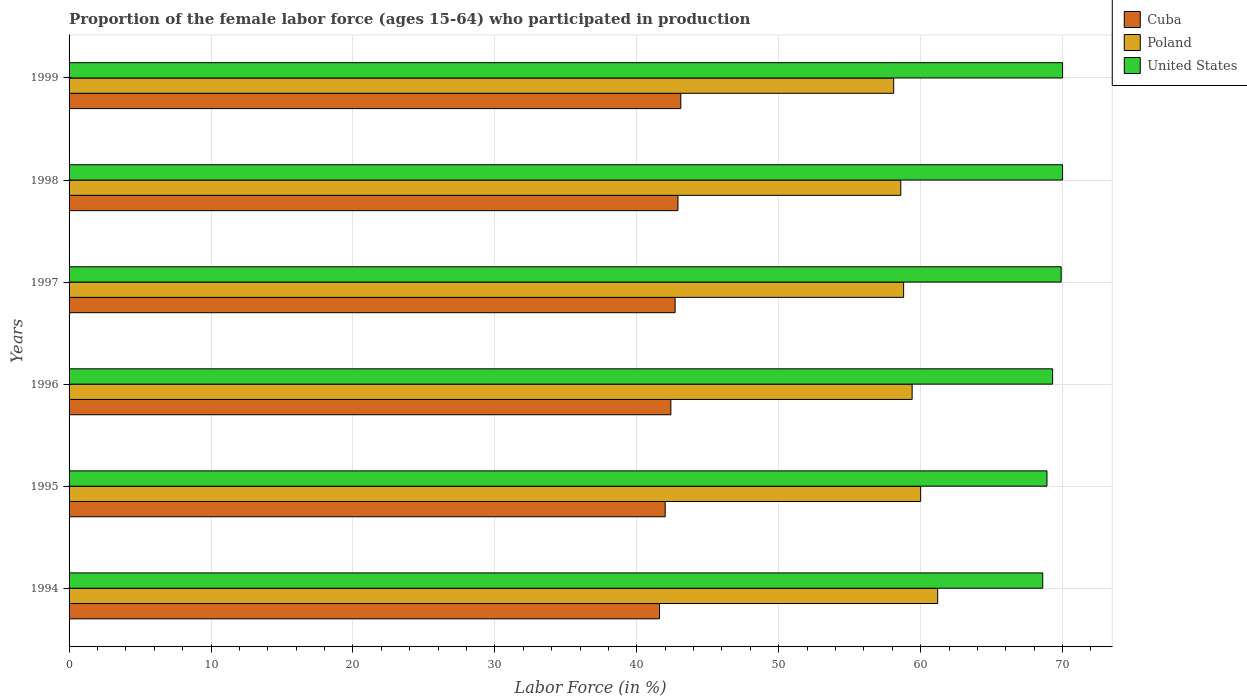How many different coloured bars are there?
Your response must be concise. 3. Are the number of bars on each tick of the Y-axis equal?
Provide a short and direct response. Yes. How many bars are there on the 2nd tick from the top?
Give a very brief answer. 3. What is the label of the 4th group of bars from the top?
Your answer should be compact. 1996. What is the proportion of the female labor force who participated in production in United States in 1995?
Provide a short and direct response. 68.9. Across all years, what is the maximum proportion of the female labor force who participated in production in United States?
Offer a very short reply. 70. Across all years, what is the minimum proportion of the female labor force who participated in production in United States?
Provide a short and direct response. 68.6. What is the total proportion of the female labor force who participated in production in Cuba in the graph?
Keep it short and to the point. 254.7. What is the difference between the proportion of the female labor force who participated in production in Poland in 1997 and the proportion of the female labor force who participated in production in Cuba in 1995?
Your answer should be very brief. 16.8. What is the average proportion of the female labor force who participated in production in Poland per year?
Your answer should be very brief. 59.35. In the year 1998, what is the difference between the proportion of the female labor force who participated in production in Poland and proportion of the female labor force who participated in production in Cuba?
Offer a terse response. 15.7. What is the ratio of the proportion of the female labor force who participated in production in Poland in 1995 to that in 1997?
Offer a terse response. 1.02. What is the difference between the highest and the second highest proportion of the female labor force who participated in production in Cuba?
Offer a very short reply. 0.2. What is the difference between the highest and the lowest proportion of the female labor force who participated in production in United States?
Your response must be concise. 1.4. In how many years, is the proportion of the female labor force who participated in production in United States greater than the average proportion of the female labor force who participated in production in United States taken over all years?
Offer a terse response. 3. Is the sum of the proportion of the female labor force who participated in production in Poland in 1994 and 1999 greater than the maximum proportion of the female labor force who participated in production in United States across all years?
Your answer should be compact. Yes. What does the 3rd bar from the top in 1997 represents?
Provide a succinct answer. Cuba. What does the 1st bar from the bottom in 1997 represents?
Provide a short and direct response. Cuba. How many bars are there?
Keep it short and to the point. 18. Are all the bars in the graph horizontal?
Ensure brevity in your answer.  Yes. What is the difference between two consecutive major ticks on the X-axis?
Provide a short and direct response. 10. Are the values on the major ticks of X-axis written in scientific E-notation?
Ensure brevity in your answer.  No. Does the graph contain grids?
Ensure brevity in your answer.  Yes. Where does the legend appear in the graph?
Keep it short and to the point. Top right. What is the title of the graph?
Offer a terse response. Proportion of the female labor force (ages 15-64) who participated in production. Does "Sub-Saharan Africa (developing only)" appear as one of the legend labels in the graph?
Your answer should be compact. No. What is the Labor Force (in %) of Cuba in 1994?
Make the answer very short. 41.6. What is the Labor Force (in %) of Poland in 1994?
Give a very brief answer. 61.2. What is the Labor Force (in %) in United States in 1994?
Offer a terse response. 68.6. What is the Labor Force (in %) in Cuba in 1995?
Provide a short and direct response. 42. What is the Labor Force (in %) of United States in 1995?
Your answer should be compact. 68.9. What is the Labor Force (in %) of Cuba in 1996?
Provide a short and direct response. 42.4. What is the Labor Force (in %) of Poland in 1996?
Keep it short and to the point. 59.4. What is the Labor Force (in %) of United States in 1996?
Provide a short and direct response. 69.3. What is the Labor Force (in %) in Cuba in 1997?
Make the answer very short. 42.7. What is the Labor Force (in %) in Poland in 1997?
Provide a succinct answer. 58.8. What is the Labor Force (in %) in United States in 1997?
Offer a very short reply. 69.9. What is the Labor Force (in %) in Cuba in 1998?
Provide a succinct answer. 42.9. What is the Labor Force (in %) in Poland in 1998?
Your response must be concise. 58.6. What is the Labor Force (in %) in Cuba in 1999?
Your response must be concise. 43.1. What is the Labor Force (in %) of Poland in 1999?
Keep it short and to the point. 58.1. What is the Labor Force (in %) of United States in 1999?
Give a very brief answer. 70. Across all years, what is the maximum Labor Force (in %) of Cuba?
Ensure brevity in your answer.  43.1. Across all years, what is the maximum Labor Force (in %) in Poland?
Make the answer very short. 61.2. Across all years, what is the maximum Labor Force (in %) of United States?
Keep it short and to the point. 70. Across all years, what is the minimum Labor Force (in %) of Cuba?
Your response must be concise. 41.6. Across all years, what is the minimum Labor Force (in %) in Poland?
Your response must be concise. 58.1. Across all years, what is the minimum Labor Force (in %) in United States?
Your answer should be compact. 68.6. What is the total Labor Force (in %) of Cuba in the graph?
Offer a very short reply. 254.7. What is the total Labor Force (in %) of Poland in the graph?
Your response must be concise. 356.1. What is the total Labor Force (in %) of United States in the graph?
Your answer should be very brief. 416.7. What is the difference between the Labor Force (in %) of Cuba in 1994 and that in 1995?
Your answer should be compact. -0.4. What is the difference between the Labor Force (in %) in Poland in 1994 and that in 1995?
Make the answer very short. 1.2. What is the difference between the Labor Force (in %) in Cuba in 1994 and that in 1997?
Your answer should be compact. -1.1. What is the difference between the Labor Force (in %) in Poland in 1994 and that in 1997?
Your answer should be compact. 2.4. What is the difference between the Labor Force (in %) of Poland in 1994 and that in 1998?
Your response must be concise. 2.6. What is the difference between the Labor Force (in %) of United States in 1994 and that in 1998?
Your response must be concise. -1.4. What is the difference between the Labor Force (in %) in Cuba in 1994 and that in 1999?
Make the answer very short. -1.5. What is the difference between the Labor Force (in %) in Poland in 1994 and that in 1999?
Your response must be concise. 3.1. What is the difference between the Labor Force (in %) in United States in 1994 and that in 1999?
Give a very brief answer. -1.4. What is the difference between the Labor Force (in %) of United States in 1995 and that in 1996?
Keep it short and to the point. -0.4. What is the difference between the Labor Force (in %) of Poland in 1995 and that in 1997?
Give a very brief answer. 1.2. What is the difference between the Labor Force (in %) in Poland in 1996 and that in 1997?
Provide a short and direct response. 0.6. What is the difference between the Labor Force (in %) of Poland in 1996 and that in 1998?
Offer a terse response. 0.8. What is the difference between the Labor Force (in %) of Poland in 1996 and that in 1999?
Keep it short and to the point. 1.3. What is the difference between the Labor Force (in %) in United States in 1996 and that in 1999?
Keep it short and to the point. -0.7. What is the difference between the Labor Force (in %) of Cuba in 1997 and that in 1999?
Provide a succinct answer. -0.4. What is the difference between the Labor Force (in %) of Poland in 1997 and that in 1999?
Your answer should be very brief. 0.7. What is the difference between the Labor Force (in %) in Poland in 1998 and that in 1999?
Give a very brief answer. 0.5. What is the difference between the Labor Force (in %) of United States in 1998 and that in 1999?
Provide a succinct answer. 0. What is the difference between the Labor Force (in %) in Cuba in 1994 and the Labor Force (in %) in Poland in 1995?
Give a very brief answer. -18.4. What is the difference between the Labor Force (in %) of Cuba in 1994 and the Labor Force (in %) of United States in 1995?
Provide a short and direct response. -27.3. What is the difference between the Labor Force (in %) of Cuba in 1994 and the Labor Force (in %) of Poland in 1996?
Offer a terse response. -17.8. What is the difference between the Labor Force (in %) in Cuba in 1994 and the Labor Force (in %) in United States in 1996?
Make the answer very short. -27.7. What is the difference between the Labor Force (in %) in Poland in 1994 and the Labor Force (in %) in United States in 1996?
Make the answer very short. -8.1. What is the difference between the Labor Force (in %) in Cuba in 1994 and the Labor Force (in %) in Poland in 1997?
Provide a short and direct response. -17.2. What is the difference between the Labor Force (in %) in Cuba in 1994 and the Labor Force (in %) in United States in 1997?
Your answer should be compact. -28.3. What is the difference between the Labor Force (in %) of Poland in 1994 and the Labor Force (in %) of United States in 1997?
Ensure brevity in your answer.  -8.7. What is the difference between the Labor Force (in %) of Cuba in 1994 and the Labor Force (in %) of United States in 1998?
Keep it short and to the point. -28.4. What is the difference between the Labor Force (in %) of Cuba in 1994 and the Labor Force (in %) of Poland in 1999?
Your answer should be compact. -16.5. What is the difference between the Labor Force (in %) in Cuba in 1994 and the Labor Force (in %) in United States in 1999?
Make the answer very short. -28.4. What is the difference between the Labor Force (in %) of Cuba in 1995 and the Labor Force (in %) of Poland in 1996?
Offer a very short reply. -17.4. What is the difference between the Labor Force (in %) in Cuba in 1995 and the Labor Force (in %) in United States in 1996?
Make the answer very short. -27.3. What is the difference between the Labor Force (in %) of Poland in 1995 and the Labor Force (in %) of United States in 1996?
Keep it short and to the point. -9.3. What is the difference between the Labor Force (in %) of Cuba in 1995 and the Labor Force (in %) of Poland in 1997?
Ensure brevity in your answer.  -16.8. What is the difference between the Labor Force (in %) of Cuba in 1995 and the Labor Force (in %) of United States in 1997?
Keep it short and to the point. -27.9. What is the difference between the Labor Force (in %) in Poland in 1995 and the Labor Force (in %) in United States in 1997?
Ensure brevity in your answer.  -9.9. What is the difference between the Labor Force (in %) of Cuba in 1995 and the Labor Force (in %) of Poland in 1998?
Offer a very short reply. -16.6. What is the difference between the Labor Force (in %) of Cuba in 1995 and the Labor Force (in %) of United States in 1998?
Offer a terse response. -28. What is the difference between the Labor Force (in %) of Cuba in 1995 and the Labor Force (in %) of Poland in 1999?
Make the answer very short. -16.1. What is the difference between the Labor Force (in %) of Cuba in 1996 and the Labor Force (in %) of Poland in 1997?
Make the answer very short. -16.4. What is the difference between the Labor Force (in %) in Cuba in 1996 and the Labor Force (in %) in United States in 1997?
Give a very brief answer. -27.5. What is the difference between the Labor Force (in %) in Cuba in 1996 and the Labor Force (in %) in Poland in 1998?
Your response must be concise. -16.2. What is the difference between the Labor Force (in %) in Cuba in 1996 and the Labor Force (in %) in United States in 1998?
Offer a terse response. -27.6. What is the difference between the Labor Force (in %) of Cuba in 1996 and the Labor Force (in %) of Poland in 1999?
Make the answer very short. -15.7. What is the difference between the Labor Force (in %) in Cuba in 1996 and the Labor Force (in %) in United States in 1999?
Ensure brevity in your answer.  -27.6. What is the difference between the Labor Force (in %) of Cuba in 1997 and the Labor Force (in %) of Poland in 1998?
Your answer should be very brief. -15.9. What is the difference between the Labor Force (in %) in Cuba in 1997 and the Labor Force (in %) in United States in 1998?
Give a very brief answer. -27.3. What is the difference between the Labor Force (in %) of Poland in 1997 and the Labor Force (in %) of United States in 1998?
Offer a very short reply. -11.2. What is the difference between the Labor Force (in %) in Cuba in 1997 and the Labor Force (in %) in Poland in 1999?
Provide a succinct answer. -15.4. What is the difference between the Labor Force (in %) of Cuba in 1997 and the Labor Force (in %) of United States in 1999?
Give a very brief answer. -27.3. What is the difference between the Labor Force (in %) of Poland in 1997 and the Labor Force (in %) of United States in 1999?
Your answer should be compact. -11.2. What is the difference between the Labor Force (in %) of Cuba in 1998 and the Labor Force (in %) of Poland in 1999?
Your answer should be compact. -15.2. What is the difference between the Labor Force (in %) in Cuba in 1998 and the Labor Force (in %) in United States in 1999?
Your answer should be very brief. -27.1. What is the average Labor Force (in %) of Cuba per year?
Provide a short and direct response. 42.45. What is the average Labor Force (in %) of Poland per year?
Provide a succinct answer. 59.35. What is the average Labor Force (in %) in United States per year?
Your answer should be compact. 69.45. In the year 1994, what is the difference between the Labor Force (in %) of Cuba and Labor Force (in %) of Poland?
Make the answer very short. -19.6. In the year 1994, what is the difference between the Labor Force (in %) of Cuba and Labor Force (in %) of United States?
Your answer should be compact. -27. In the year 1995, what is the difference between the Labor Force (in %) in Cuba and Labor Force (in %) in United States?
Your response must be concise. -26.9. In the year 1996, what is the difference between the Labor Force (in %) in Cuba and Labor Force (in %) in United States?
Your answer should be very brief. -26.9. In the year 1996, what is the difference between the Labor Force (in %) of Poland and Labor Force (in %) of United States?
Provide a short and direct response. -9.9. In the year 1997, what is the difference between the Labor Force (in %) of Cuba and Labor Force (in %) of Poland?
Give a very brief answer. -16.1. In the year 1997, what is the difference between the Labor Force (in %) in Cuba and Labor Force (in %) in United States?
Offer a terse response. -27.2. In the year 1998, what is the difference between the Labor Force (in %) in Cuba and Labor Force (in %) in Poland?
Offer a terse response. -15.7. In the year 1998, what is the difference between the Labor Force (in %) in Cuba and Labor Force (in %) in United States?
Ensure brevity in your answer.  -27.1. In the year 1999, what is the difference between the Labor Force (in %) of Cuba and Labor Force (in %) of Poland?
Provide a succinct answer. -15. In the year 1999, what is the difference between the Labor Force (in %) of Cuba and Labor Force (in %) of United States?
Give a very brief answer. -26.9. What is the ratio of the Labor Force (in %) of Cuba in 1994 to that in 1995?
Offer a terse response. 0.99. What is the ratio of the Labor Force (in %) in Poland in 1994 to that in 1995?
Offer a very short reply. 1.02. What is the ratio of the Labor Force (in %) in United States in 1994 to that in 1995?
Keep it short and to the point. 1. What is the ratio of the Labor Force (in %) of Cuba in 1994 to that in 1996?
Ensure brevity in your answer.  0.98. What is the ratio of the Labor Force (in %) in Poland in 1994 to that in 1996?
Your answer should be compact. 1.03. What is the ratio of the Labor Force (in %) of United States in 1994 to that in 1996?
Your answer should be compact. 0.99. What is the ratio of the Labor Force (in %) in Cuba in 1994 to that in 1997?
Your response must be concise. 0.97. What is the ratio of the Labor Force (in %) in Poland in 1994 to that in 1997?
Your answer should be compact. 1.04. What is the ratio of the Labor Force (in %) of United States in 1994 to that in 1997?
Provide a short and direct response. 0.98. What is the ratio of the Labor Force (in %) in Cuba in 1994 to that in 1998?
Your answer should be very brief. 0.97. What is the ratio of the Labor Force (in %) in Poland in 1994 to that in 1998?
Ensure brevity in your answer.  1.04. What is the ratio of the Labor Force (in %) in Cuba in 1994 to that in 1999?
Your answer should be compact. 0.97. What is the ratio of the Labor Force (in %) of Poland in 1994 to that in 1999?
Your response must be concise. 1.05. What is the ratio of the Labor Force (in %) of Cuba in 1995 to that in 1996?
Give a very brief answer. 0.99. What is the ratio of the Labor Force (in %) of Poland in 1995 to that in 1996?
Keep it short and to the point. 1.01. What is the ratio of the Labor Force (in %) of United States in 1995 to that in 1996?
Your response must be concise. 0.99. What is the ratio of the Labor Force (in %) in Cuba in 1995 to that in 1997?
Offer a terse response. 0.98. What is the ratio of the Labor Force (in %) in Poland in 1995 to that in 1997?
Your response must be concise. 1.02. What is the ratio of the Labor Force (in %) of United States in 1995 to that in 1997?
Provide a short and direct response. 0.99. What is the ratio of the Labor Force (in %) of Poland in 1995 to that in 1998?
Keep it short and to the point. 1.02. What is the ratio of the Labor Force (in %) of United States in 1995 to that in 1998?
Provide a short and direct response. 0.98. What is the ratio of the Labor Force (in %) in Cuba in 1995 to that in 1999?
Ensure brevity in your answer.  0.97. What is the ratio of the Labor Force (in %) of Poland in 1995 to that in 1999?
Offer a terse response. 1.03. What is the ratio of the Labor Force (in %) of United States in 1995 to that in 1999?
Your response must be concise. 0.98. What is the ratio of the Labor Force (in %) of Cuba in 1996 to that in 1997?
Your answer should be compact. 0.99. What is the ratio of the Labor Force (in %) of Poland in 1996 to that in 1997?
Provide a succinct answer. 1.01. What is the ratio of the Labor Force (in %) of United States in 1996 to that in 1997?
Provide a succinct answer. 0.99. What is the ratio of the Labor Force (in %) in Cuba in 1996 to that in 1998?
Provide a short and direct response. 0.99. What is the ratio of the Labor Force (in %) in Poland in 1996 to that in 1998?
Offer a terse response. 1.01. What is the ratio of the Labor Force (in %) of United States in 1996 to that in 1998?
Keep it short and to the point. 0.99. What is the ratio of the Labor Force (in %) of Cuba in 1996 to that in 1999?
Provide a short and direct response. 0.98. What is the ratio of the Labor Force (in %) in Poland in 1996 to that in 1999?
Keep it short and to the point. 1.02. What is the ratio of the Labor Force (in %) of United States in 1996 to that in 1999?
Keep it short and to the point. 0.99. What is the ratio of the Labor Force (in %) of Cuba in 1997 to that in 1998?
Provide a succinct answer. 1. What is the ratio of the Labor Force (in %) of United States in 1997 to that in 1998?
Provide a succinct answer. 1. What is the ratio of the Labor Force (in %) of Cuba in 1997 to that in 1999?
Offer a terse response. 0.99. What is the ratio of the Labor Force (in %) of Cuba in 1998 to that in 1999?
Your response must be concise. 1. What is the ratio of the Labor Force (in %) in Poland in 1998 to that in 1999?
Your answer should be compact. 1.01. What is the difference between the highest and the second highest Labor Force (in %) in Poland?
Provide a short and direct response. 1.2. What is the difference between the highest and the second highest Labor Force (in %) of United States?
Your answer should be very brief. 0. What is the difference between the highest and the lowest Labor Force (in %) of Poland?
Give a very brief answer. 3.1. What is the difference between the highest and the lowest Labor Force (in %) in United States?
Ensure brevity in your answer.  1.4. 